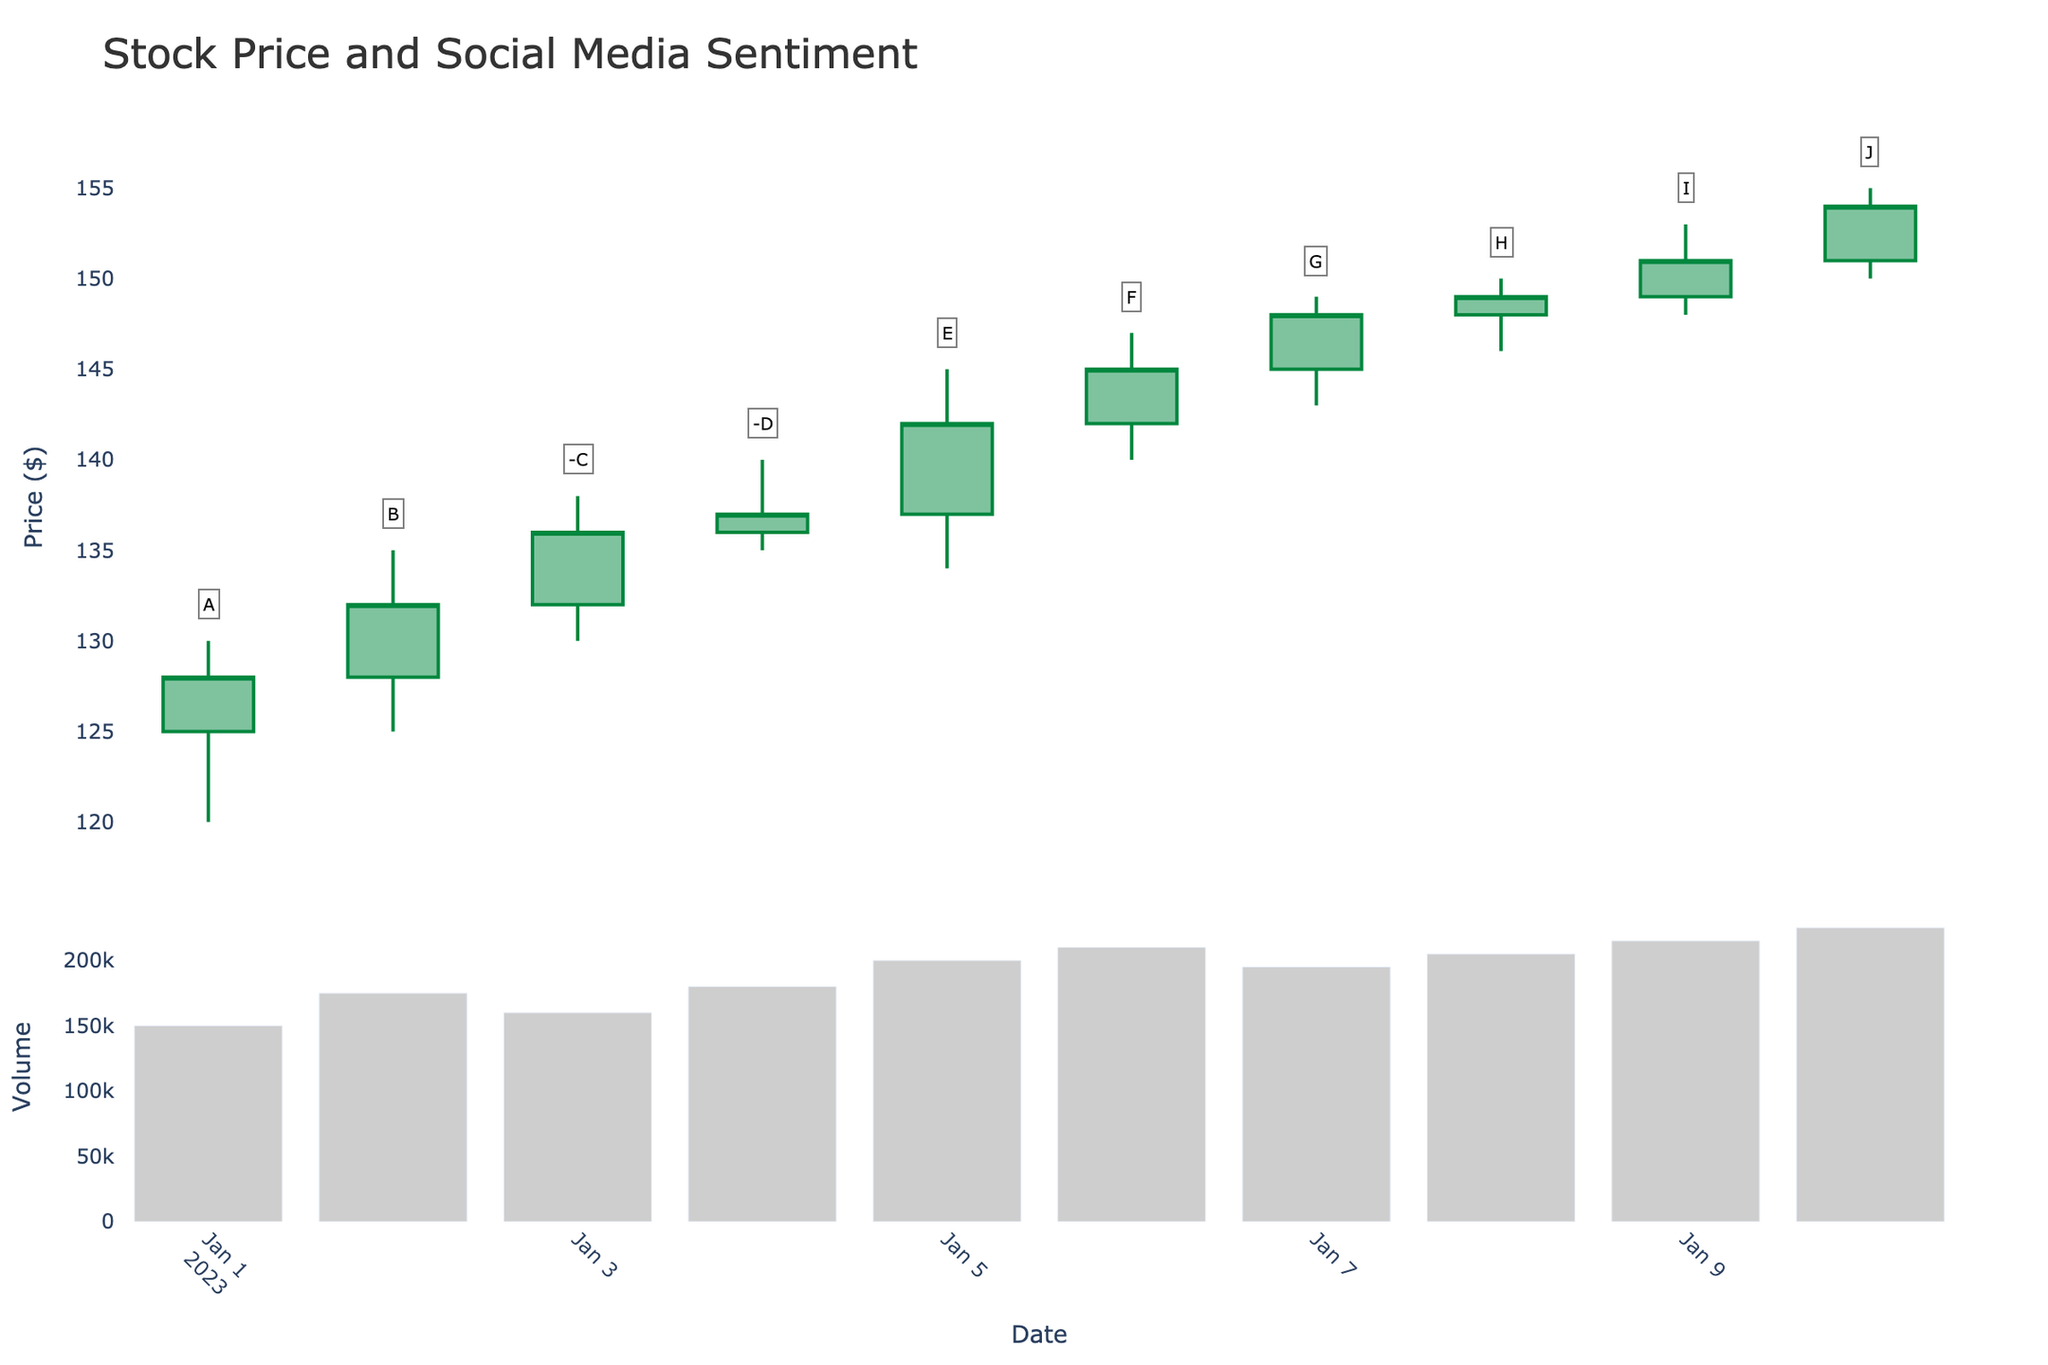What is the title of the figure? The title of the figure is displayed prominently at the top center of the figure. It helps to identify the main subject portrayed by the chart.
Answer: Stock Price and Social Media Sentiment How many data points are represented in the figure? The figure contains data points for each date present in the dataset. By counting the dates on the x-axis, we can find the number of data points.
Answer: 10 On which date did the highest closing price occur? By examining the candlestick plot and checking the upper limits of the closing price for each candlestick, we can determine the date with the highest closing price.
Answer: 2023-01-10 What was the stock volume on January 10th? The volume bar chart below the candlestick plot displays the volume for each date. By locating January 10th on the x-axis, we can find the corresponding volume bar height.
Answer: 225000 When was the first instance of a negative social media sentiment marked, and what was the closing price on that day? We can spot the negative sentiments by looking for negative markers (-C, -D) annotated on the candlesticks. The closing price is the upper end of the solid part of each candlestick for the specified date.
Answer: 2023-01-03, closing price: 136 How did the social media sentiment "E" on January 05th affect the stock price the next day? Look at the candlestick for January 05th and then compare it with the candlestick on January 06th to see the change in stock prices (open, close) to infer the sentiment's impact.
Answer: The price increased from 137 to 145 What is the average trading volume over the 10-day period? Sum the volumes of all the days and then divide by the total number of days to find the average.
Answer: (150000 + 175000 + 160000 + 180000 + 200000 + 210000 + 195000 + 205000 + 215000 + 225000) / 10 = 191500 Which day experienced the largest price range and what was that range? Calculate the difference between the high and low for each day and compare. The day with the largest difference is the one with the largest price range.
Answer: 2023-01-05, range: 11 Is there a correlation between increasing trading volume and stock price trends in this figure? Examine if there are instances where the trading volume increases and the stock price also shows a clear trend (increasing or decreasing) on the candlestick plot.
Answer: Yes, generally shows increasing 